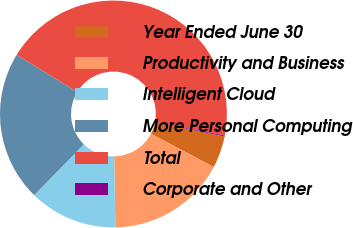Convert chart to OTSL. <chart><loc_0><loc_0><loc_500><loc_500><pie_chart><fcel>Year Ended June 30<fcel>Productivity and Business<fcel>Intelligent Cloud<fcel>More Personal Computing<fcel>Total<fcel>Corporate and Other<nl><fcel>4.56%<fcel>16.99%<fcel>12.58%<fcel>21.41%<fcel>44.32%<fcel>0.14%<nl></chart> 